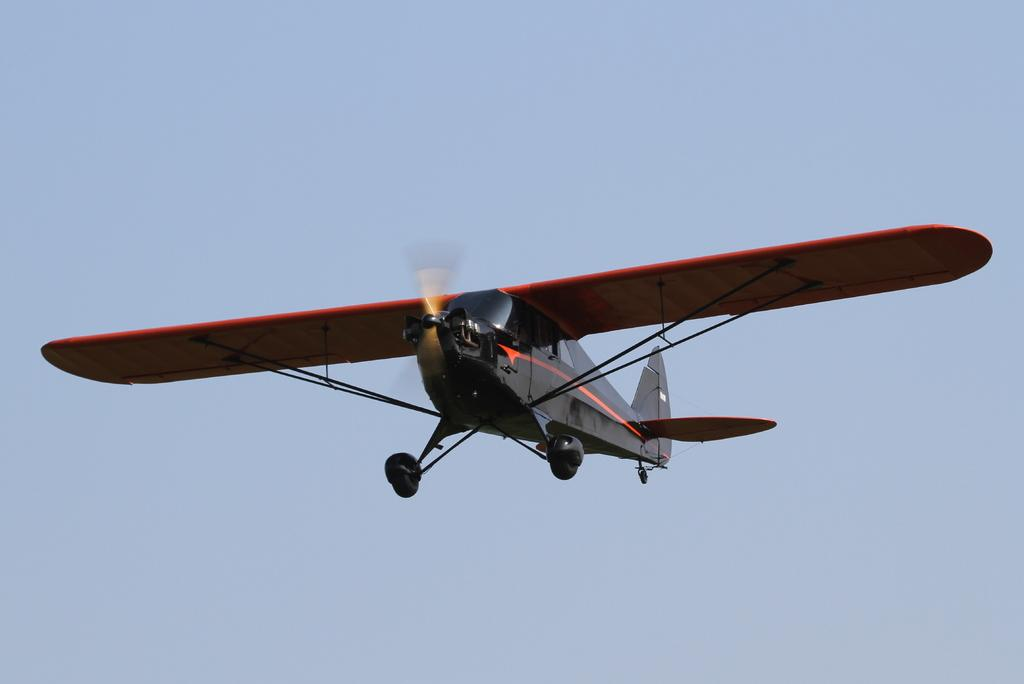Where was the image taken? The image is taken outdoors. What can be seen in the background of the image? There is a sky visible in the background of the image. What is happening in the sky in the middle of the image? An airplane is flying in the sky in the middle of the image. What type of rifle can be seen in the image? There is no rifle present in the image. Which direction is the train moving in the image? There is no train present in the image. 